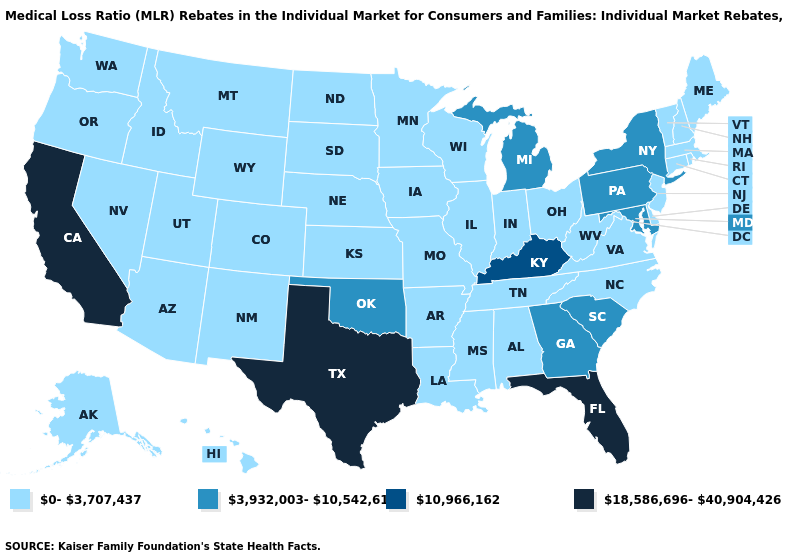What is the value of Minnesota?
Short answer required. 0-3,707,437. Name the states that have a value in the range 18,586,696-40,904,426?
Keep it brief. California, Florida, Texas. What is the lowest value in the USA?
Give a very brief answer. 0-3,707,437. What is the highest value in the USA?
Answer briefly. 18,586,696-40,904,426. Among the states that border Mississippi , which have the highest value?
Give a very brief answer. Alabama, Arkansas, Louisiana, Tennessee. Does Alaska have the lowest value in the USA?
Give a very brief answer. Yes. Which states have the lowest value in the MidWest?
Concise answer only. Illinois, Indiana, Iowa, Kansas, Minnesota, Missouri, Nebraska, North Dakota, Ohio, South Dakota, Wisconsin. Does the first symbol in the legend represent the smallest category?
Concise answer only. Yes. What is the value of Indiana?
Write a very short answer. 0-3,707,437. What is the value of Hawaii?
Give a very brief answer. 0-3,707,437. What is the value of California?
Give a very brief answer. 18,586,696-40,904,426. Name the states that have a value in the range 10,966,162?
Quick response, please. Kentucky. What is the value of Virginia?
Keep it brief. 0-3,707,437. Is the legend a continuous bar?
Write a very short answer. No. Is the legend a continuous bar?
Concise answer only. No. 